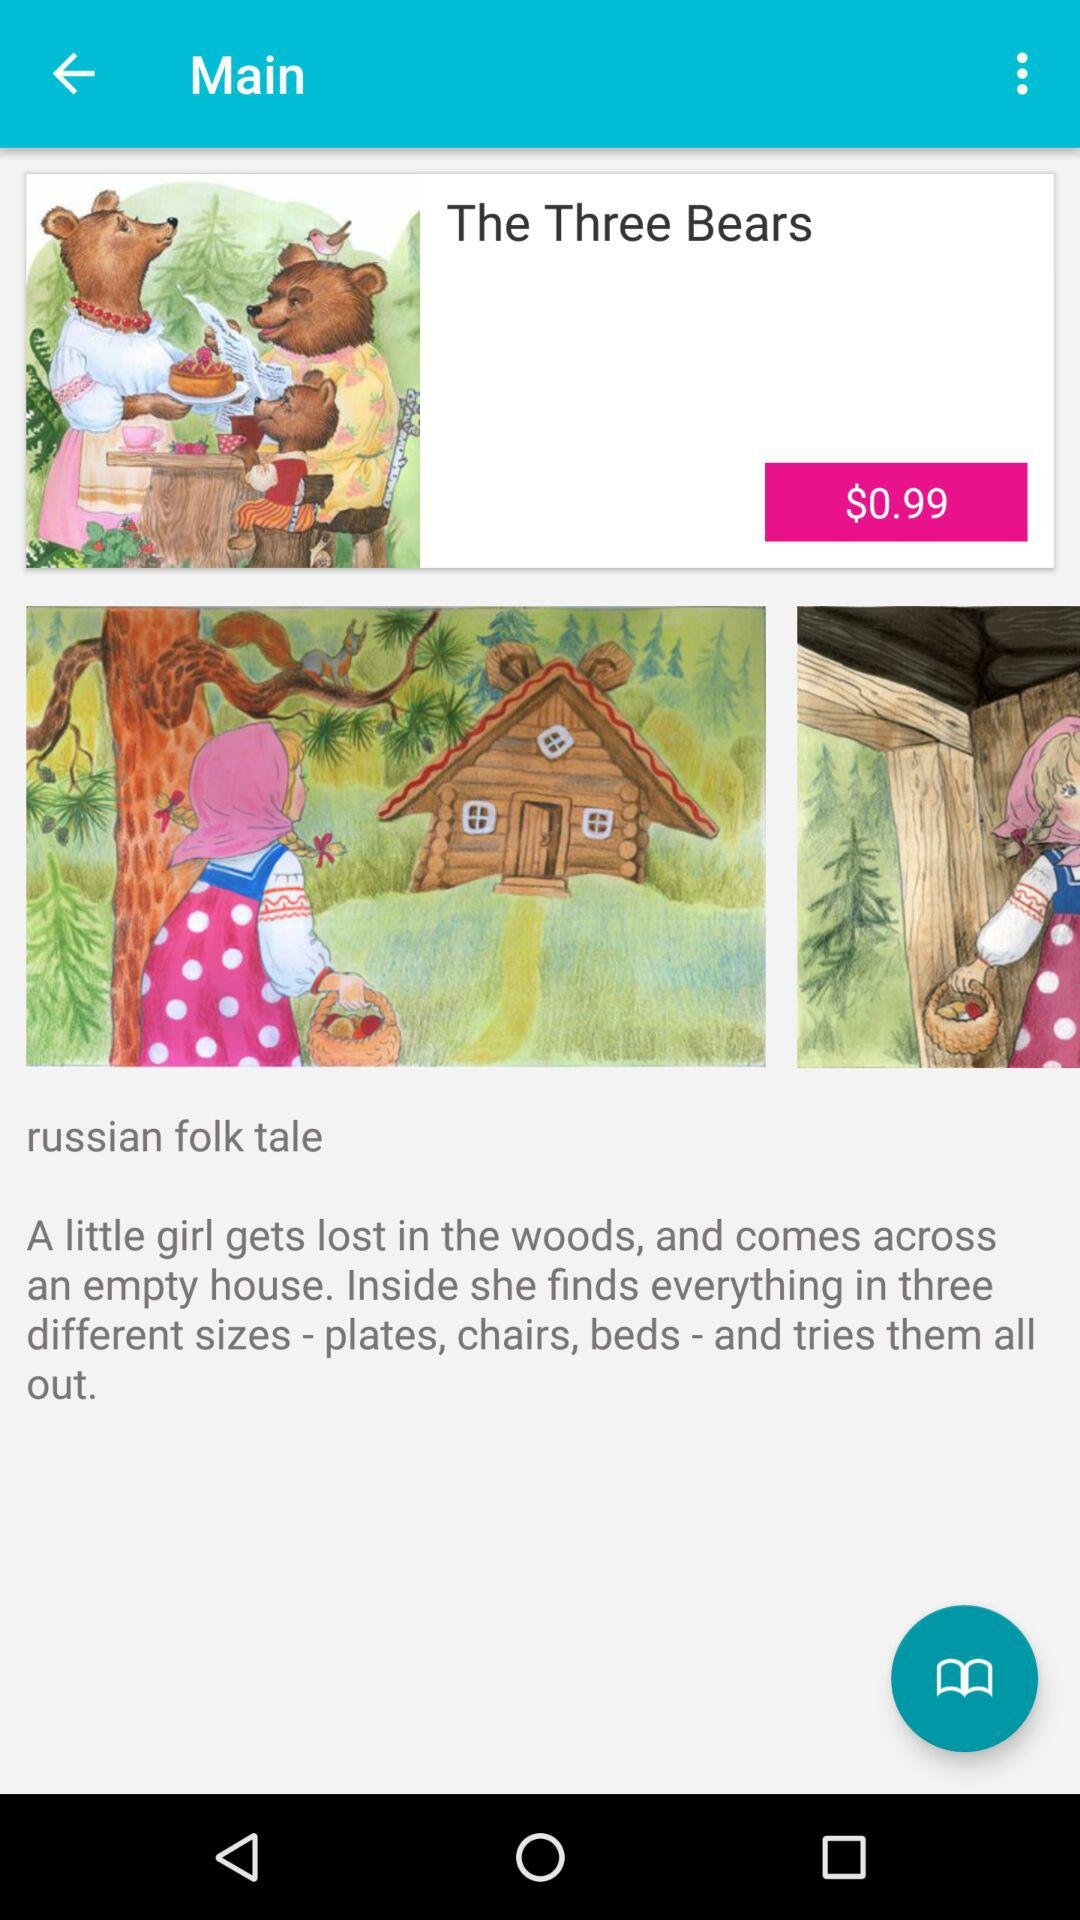How much is the price of the book?
Answer the question using a single word or phrase. $0.99 